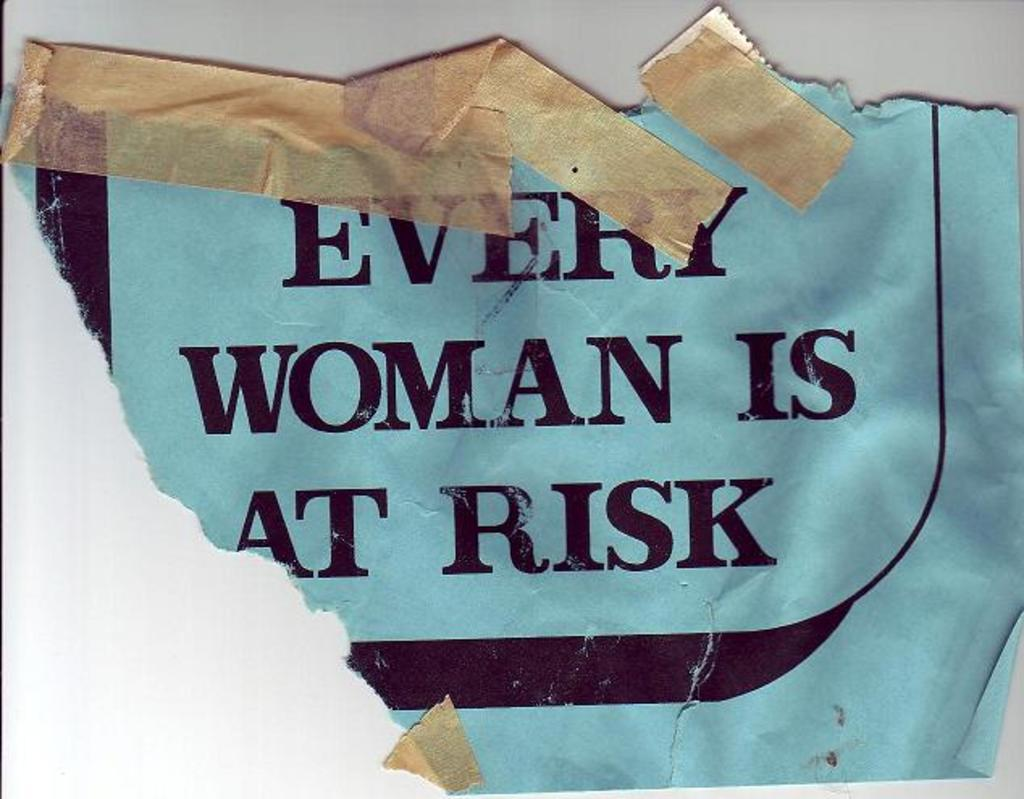<image>
Provide a brief description of the given image. A torn piece of paper that is taped that reads "EVERY WOMAN IS AT RISK". 